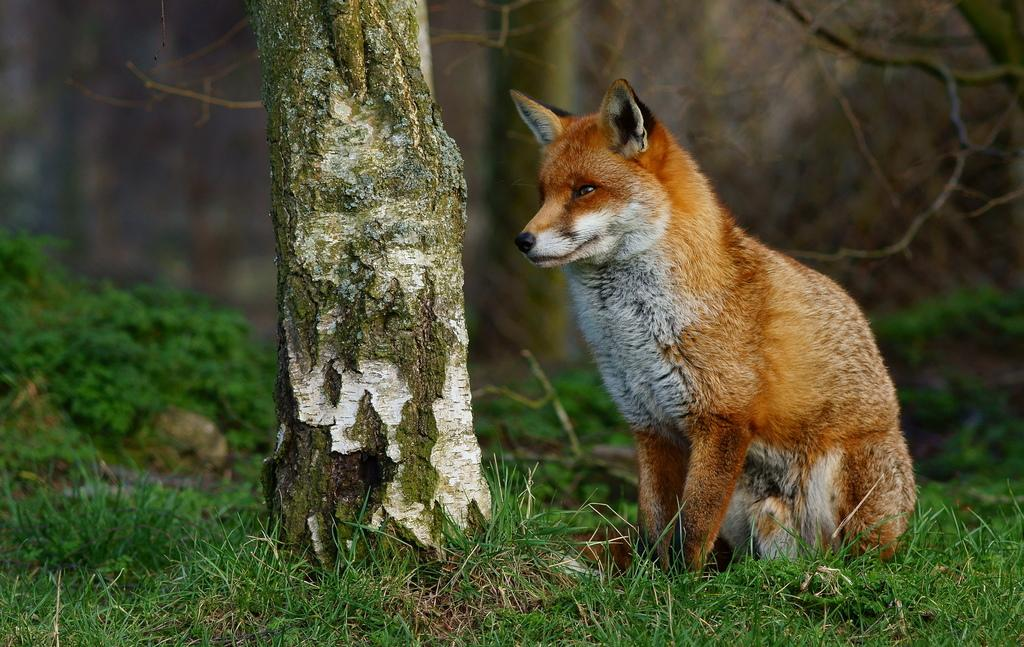What type of animal can be seen in the image? There is an animal in the image, but the specific type cannot be determined from the provided facts. Where is the animal located in the image? The animal is on the grass in the image. What other natural elements are present in the image? There are trees and plants in the image. How would you describe the background of the image? The background of the image is blurred. What type of door can be seen in the image? There is no door present in the image; it features an animal on the grass with trees and plants in the background. 